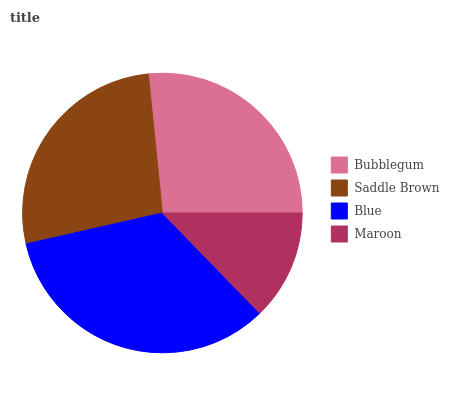Is Maroon the minimum?
Answer yes or no. Yes. Is Blue the maximum?
Answer yes or no. Yes. Is Saddle Brown the minimum?
Answer yes or no. No. Is Saddle Brown the maximum?
Answer yes or no. No. Is Saddle Brown greater than Bubblegum?
Answer yes or no. Yes. Is Bubblegum less than Saddle Brown?
Answer yes or no. Yes. Is Bubblegum greater than Saddle Brown?
Answer yes or no. No. Is Saddle Brown less than Bubblegum?
Answer yes or no. No. Is Saddle Brown the high median?
Answer yes or no. Yes. Is Bubblegum the low median?
Answer yes or no. Yes. Is Bubblegum the high median?
Answer yes or no. No. Is Maroon the low median?
Answer yes or no. No. 